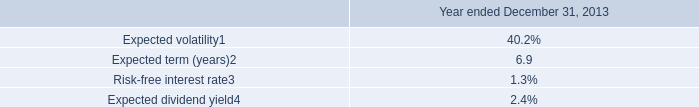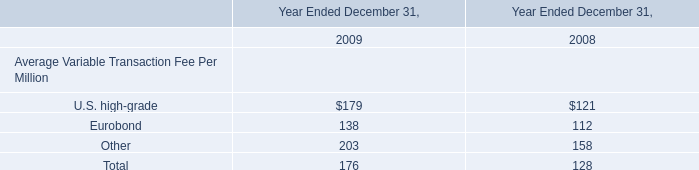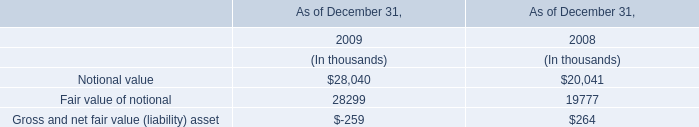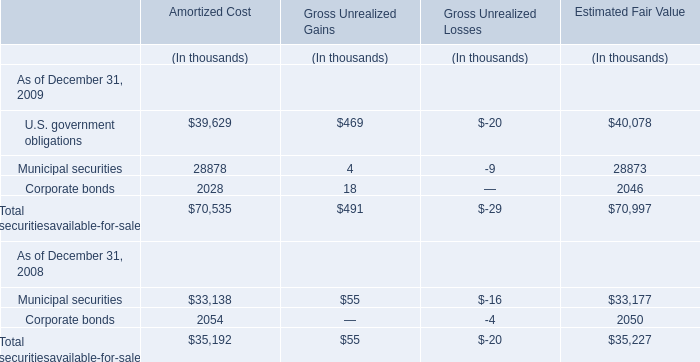What was the total amount of Fair value of notional in 2008? (in thousand) 
Answer: 19777. If Municipal securities at Estimated Fair Value develops with the same growth rate at December 31, 2009 , what will it reach at December 31, 2010 ? (in thousand) 
Computations: (28873 * (1 + ((28873 - 33177) / 33177)))
Answer: 25127.35115. 